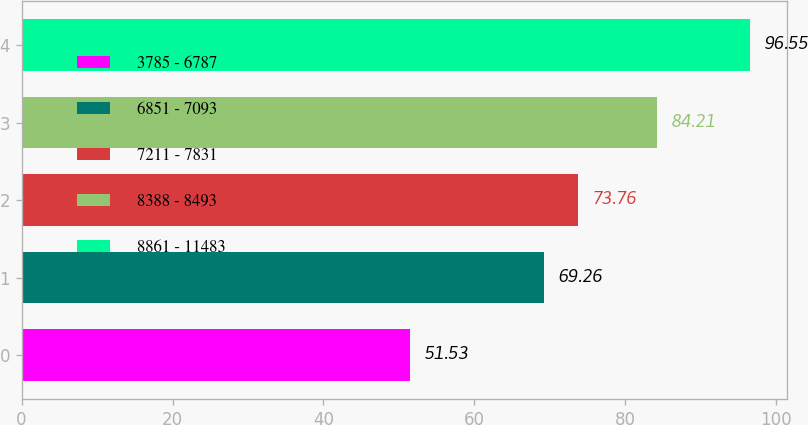Convert chart to OTSL. <chart><loc_0><loc_0><loc_500><loc_500><bar_chart><fcel>3785 - 6787<fcel>6851 - 7093<fcel>7211 - 7831<fcel>8388 - 8493<fcel>8861 - 11483<nl><fcel>51.53<fcel>69.26<fcel>73.76<fcel>84.21<fcel>96.55<nl></chart> 